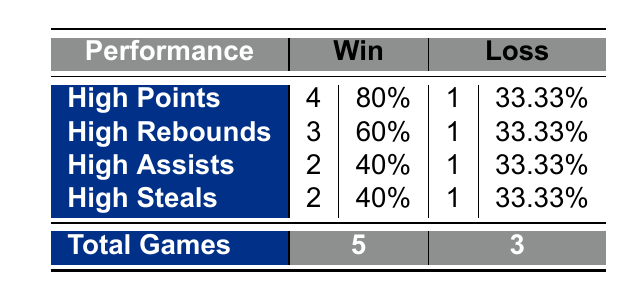What is the total number of games analyzed in the table? The table shows a total for both win and loss outcomes. For wins, there are 5 games, and for losses, there are 3 games. Adding these together gives a total of 5 + 3 = 8 games.
Answer: 8 How many players achieved high points while winning? The table indicates that 4 players had high points when the team won. To find this, simply refer to the row labeled "High Points" under the "Win" column.
Answer: 4 Is it true that the percentage of wins with high assists is greater than that of losses? In the table, for wins with high assists, the percentage is 40%, and for losses, it is 33.33%. Since 40% is greater than 33.33%, the answer is yes.
Answer: Yes What is the ratio of total wins to total losses? The table indicates 5 wins and 3 losses. The ratio of wins to losses is calculated by writing it as 5:3, which also can be expressed as a fraction 5/3.
Answer: 5:3 How many players recorded high rebounds and still contributed to winning? According to the table, 3 players had high rebounds during wins, which can be seen in the row for "High Rebounds" under the "Win" column.
Answer: 3 What is the average percentage of wins among players who had high steals? For high steals, 2 players recorded wins (40%) and 1 recorded a loss (33.33%). To find the average, you sum the win percentages (40 + 33.33) = 73.33 and divide by 2 (73.33/2) which gives an average of 36.665%.
Answer: 36.67% Did more players have high points or high assists when they lost? The table shows 1 player with high points in the loss category and 1 player with high assists in that same category. Since both numbers are equal, the answer is neither.
Answer: Neither What percentage of total wins came from players with high steals? There are a total of 5 win outcomes and 2 of those involved high steals. The percentage is calculated as (2/5)*100 = 40%.
Answer: 40% 